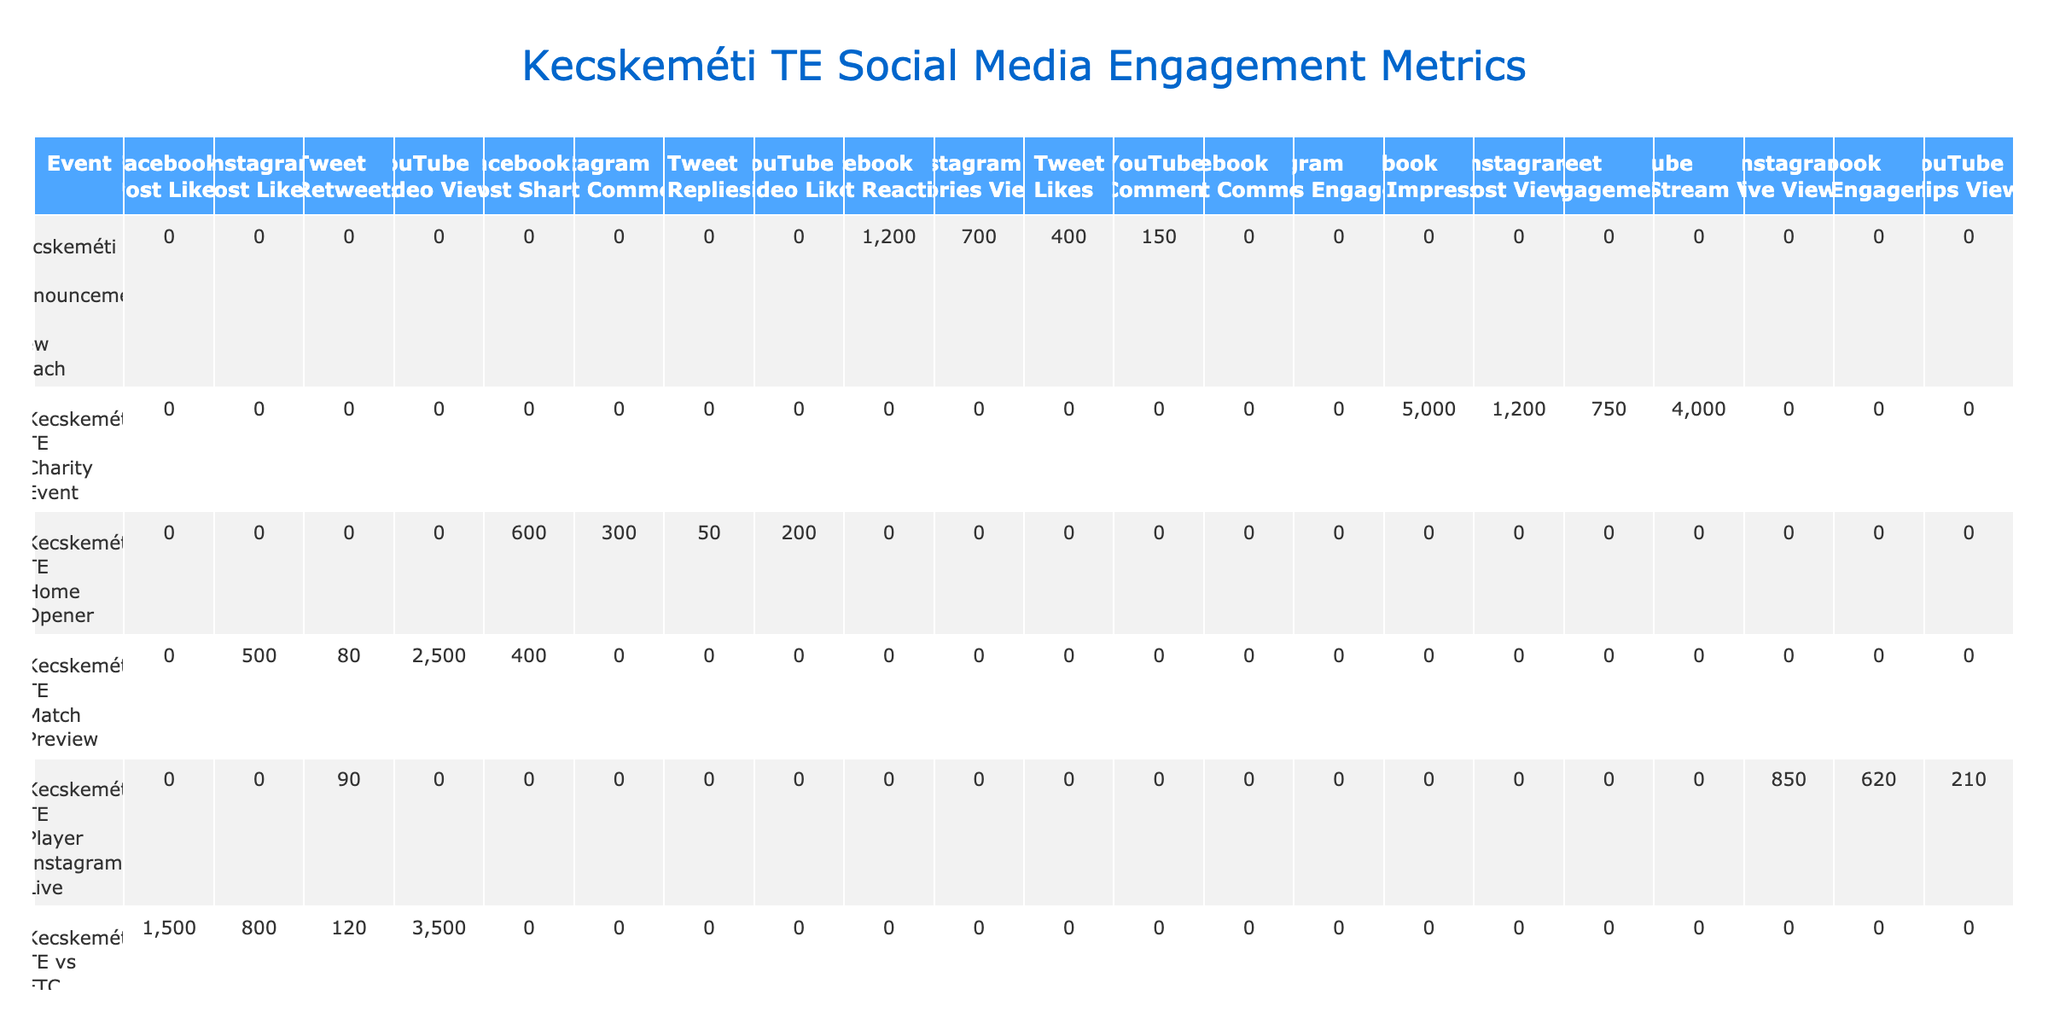What was the total engagement count on Facebook for the event "Kecskeméti TE vs FTC"? The table shows that the engagement count for the event "Kecskeméti TE vs FTC" on Facebook for various engagement types: Post Likes (1500). Since there are no other engagement types listed for Facebook in this event, the total engagement count is simply 1500.
Answer: 1500 Which event had the highest number of video views? Looking at the table, "Kecskeméti TE vs FTC" has the highest Video Views with 3500, compared to other events which have lower video counts. No other event exceeds this number for Video Views.
Answer: 3500 Did "Kecskeméti TE Home Opener" have more post shares or post comments on Facebook? The table shows that "Kecskeméti TE Home Opener" had 600 Post Shares and 0 Post Comments on Facebook. Since 600 > 0, it had more post shares than comments.
Answer: Yes, it had more post shares What is the total engagement count across all platforms for the event "Kecskeméti TE Charity Event"? For the "Kecskeméti TE Charity Event," we add the following: Facebook Post Impressions (5000), Instagram Post Views (1200), Tweet Engagements (750), YouTube Live Stream Views (4000). Summing these gives 5000 + 1200 + 750 + 4000 = 10750.
Answer: 10750 Which engagement type on Instagram had the lowest count for any event, and what was that count? The engagement type that had the lowest count on Instagram is "Post Likes" for the "Kecskeméti TE Match Preview" event with a count of 500. Comparing all Instagram counts shows that this was the lowest.
Answer: 500 What was the average engagement count for "Likes" on Tweets across all events? Looking at the table, "Likes" on Tweets occurred in three events: "Kecskeméti TE vs FTC" with 120, "Kecskeméti TE Announcement of New Coach" with 400, and "Kecskeméti TE vs Puskás Akadémia" with 300. The total is 120 + 400 + 300 = 820, and the average number of events is 3. Therefore, the average is 820 / 3 = approximately 273.33.
Answer: Approximately 273.33 What platform received the most engagements for the "Kecskeméti TE Player Instagram Live" event? For the "Kecskeméti TE Player Instagram Live," we have Post Engagements on Facebook (620), Live Views on Instagram (850), Retweets on Twitter (90), and Clips Views on YouTube (210). The highest is 850 on Instagram.
Answer: Instagram received the most engagements Was the engagement for "Kecskeméti TE vs Puskás Akadémia" higher on Facebook or Instagram? On Facebook, the engagement for "Kecskeméti TE vs Puskás Akadémia" was 200 for Post Comments. On Instagram, it was 650 for Stories Engagement. Since 650 > 200, the engagement was higher on Instagram.
Answer: Higher on Instagram How does the engagement count for the "Kecskeméti TE vs FTC" event compare to the "Kecskeméti TE vs Puskás Akadémia" event across all platforms? Summing the engagement counts for both events: Kecskeméti TE vs FTC = 1500 (Likes on Facebook) + 800 (Likes on Instagram) + 120 (Retweets on Tweet) + 3500 (Views on YouTube) = 4900. Kecskeméti TE vs Puskás Akadémia = 200 (Comments on Facebook) + 650 (Stories Engagement on Instagram) + 300 (Likes on Tweet) + 180 (Likes on YouTube) = 1330. Comparing gives 4900 > 1330.
Answer: Kecskeméti TE vs FTC had more engagement What engagement type on YouTube had the lowest count for any event? In the table, there are four counts of engagement types on YouTube: "Video Views" had 3500 (Kecskeméti TE vs FTC), "Video Likes" had 180 (Kecskeméti TE vs Puskás Akadémia), "Comment" had 150 (Kecskeméti TE Announcement of New Coach), and "Live Stream Views" had 4000 (Kecskeméti TE Charity Event). Among these, 180 is the lowest count for Video Likes.
Answer: Video Likes with a count of 180 is the lowest 